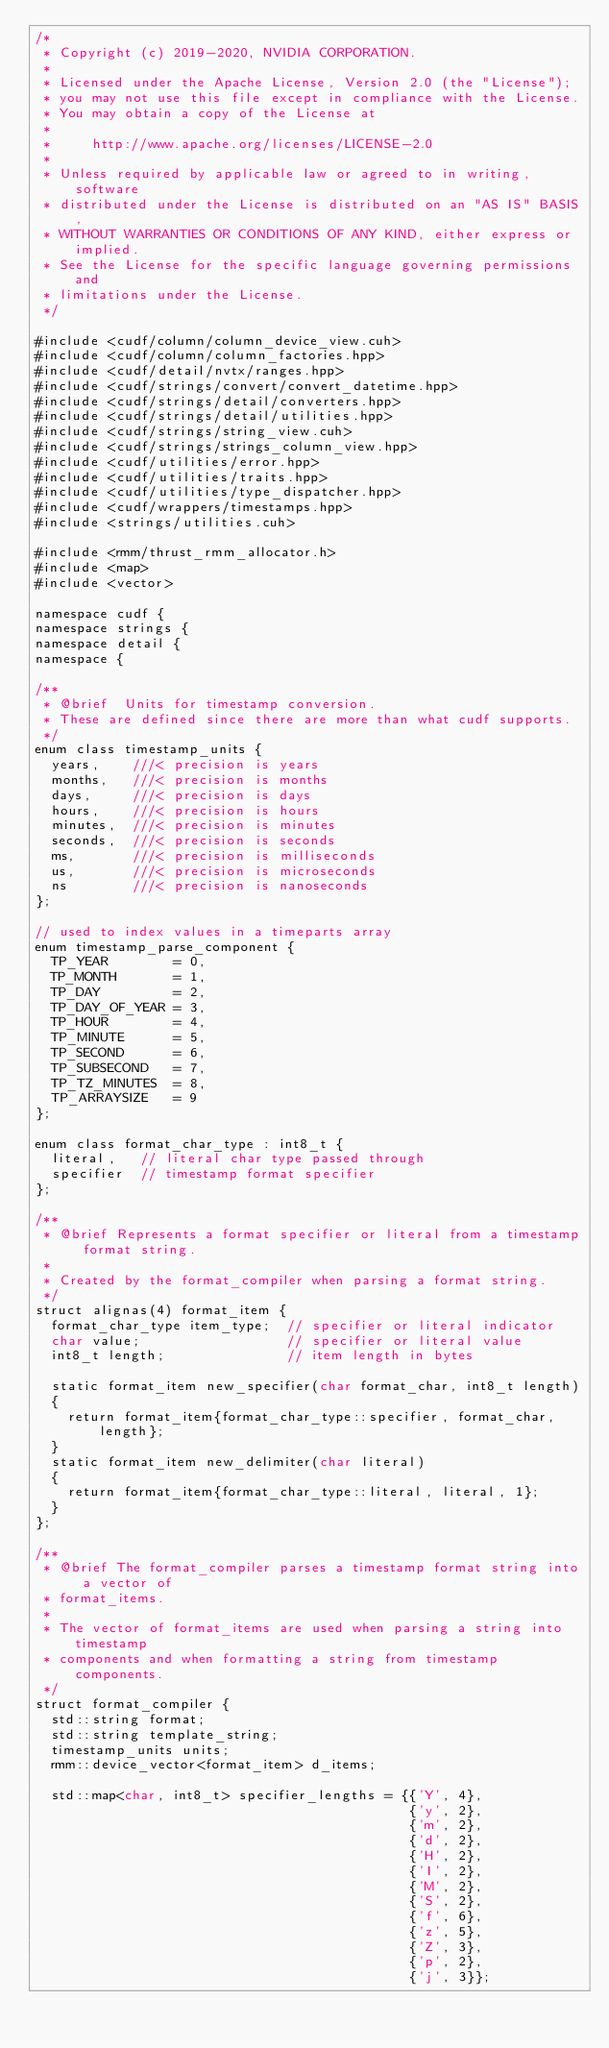<code> <loc_0><loc_0><loc_500><loc_500><_Cuda_>/*
 * Copyright (c) 2019-2020, NVIDIA CORPORATION.
 *
 * Licensed under the Apache License, Version 2.0 (the "License");
 * you may not use this file except in compliance with the License.
 * You may obtain a copy of the License at
 *
 *     http://www.apache.org/licenses/LICENSE-2.0
 *
 * Unless required by applicable law or agreed to in writing, software
 * distributed under the License is distributed on an "AS IS" BASIS,
 * WITHOUT WARRANTIES OR CONDITIONS OF ANY KIND, either express or implied.
 * See the License for the specific language governing permissions and
 * limitations under the License.
 */

#include <cudf/column/column_device_view.cuh>
#include <cudf/column/column_factories.hpp>
#include <cudf/detail/nvtx/ranges.hpp>
#include <cudf/strings/convert/convert_datetime.hpp>
#include <cudf/strings/detail/converters.hpp>
#include <cudf/strings/detail/utilities.hpp>
#include <cudf/strings/string_view.cuh>
#include <cudf/strings/strings_column_view.hpp>
#include <cudf/utilities/error.hpp>
#include <cudf/utilities/traits.hpp>
#include <cudf/utilities/type_dispatcher.hpp>
#include <cudf/wrappers/timestamps.hpp>
#include <strings/utilities.cuh>

#include <rmm/thrust_rmm_allocator.h>
#include <map>
#include <vector>

namespace cudf {
namespace strings {
namespace detail {
namespace {

/**
 * @brief  Units for timestamp conversion.
 * These are defined since there are more than what cudf supports.
 */
enum class timestamp_units {
  years,    ///< precision is years
  months,   ///< precision is months
  days,     ///< precision is days
  hours,    ///< precision is hours
  minutes,  ///< precision is minutes
  seconds,  ///< precision is seconds
  ms,       ///< precision is milliseconds
  us,       ///< precision is microseconds
  ns        ///< precision is nanoseconds
};

// used to index values in a timeparts array
enum timestamp_parse_component {
  TP_YEAR        = 0,
  TP_MONTH       = 1,
  TP_DAY         = 2,
  TP_DAY_OF_YEAR = 3,
  TP_HOUR        = 4,
  TP_MINUTE      = 5,
  TP_SECOND      = 6,
  TP_SUBSECOND   = 7,
  TP_TZ_MINUTES  = 8,
  TP_ARRAYSIZE   = 9
};

enum class format_char_type : int8_t {
  literal,   // literal char type passed through
  specifier  // timestamp format specifier
};

/**
 * @brief Represents a format specifier or literal from a timestamp format string.
 *
 * Created by the format_compiler when parsing a format string.
 */
struct alignas(4) format_item {
  format_char_type item_type;  // specifier or literal indicator
  char value;                  // specifier or literal value
  int8_t length;               // item length in bytes

  static format_item new_specifier(char format_char, int8_t length)
  {
    return format_item{format_char_type::specifier, format_char, length};
  }
  static format_item new_delimiter(char literal)
  {
    return format_item{format_char_type::literal, literal, 1};
  }
};

/**
 * @brief The format_compiler parses a timestamp format string into a vector of
 * format_items.
 *
 * The vector of format_items are used when parsing a string into timestamp
 * components and when formatting a string from timestamp components.
 */
struct format_compiler {
  std::string format;
  std::string template_string;
  timestamp_units units;
  rmm::device_vector<format_item> d_items;

  std::map<char, int8_t> specifier_lengths = {{'Y', 4},
                                              {'y', 2},
                                              {'m', 2},
                                              {'d', 2},
                                              {'H', 2},
                                              {'I', 2},
                                              {'M', 2},
                                              {'S', 2},
                                              {'f', 6},
                                              {'z', 5},
                                              {'Z', 3},
                                              {'p', 2},
                                              {'j', 3}};
</code> 